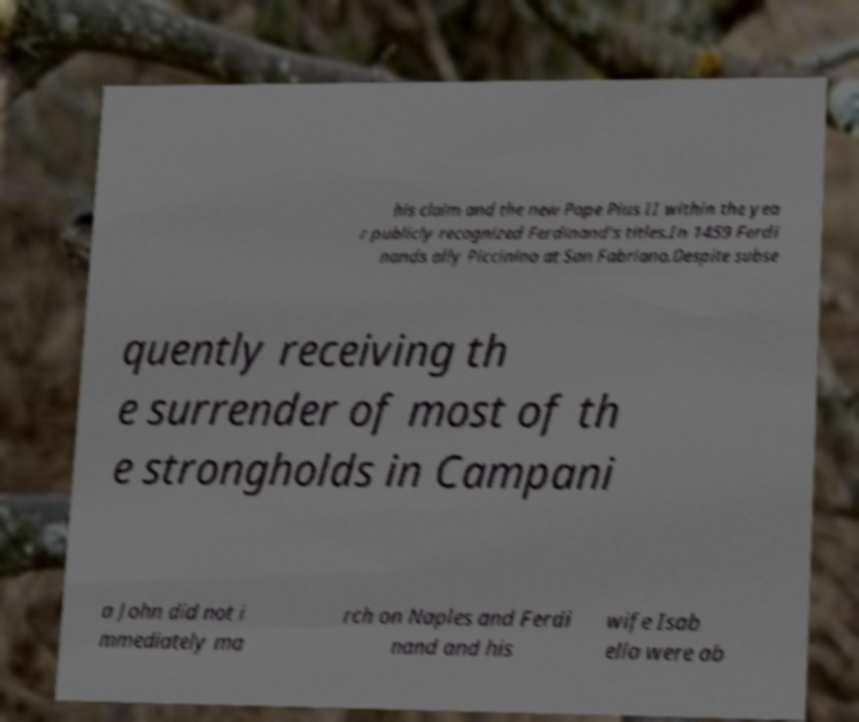Could you extract and type out the text from this image? his claim and the new Pope Pius II within the yea r publicly recognized Ferdinand's titles.In 1459 Ferdi nands ally Piccinino at San Fabriano.Despite subse quently receiving th e surrender of most of th e strongholds in Campani a John did not i mmediately ma rch on Naples and Ferdi nand and his wife Isab ella were ab 